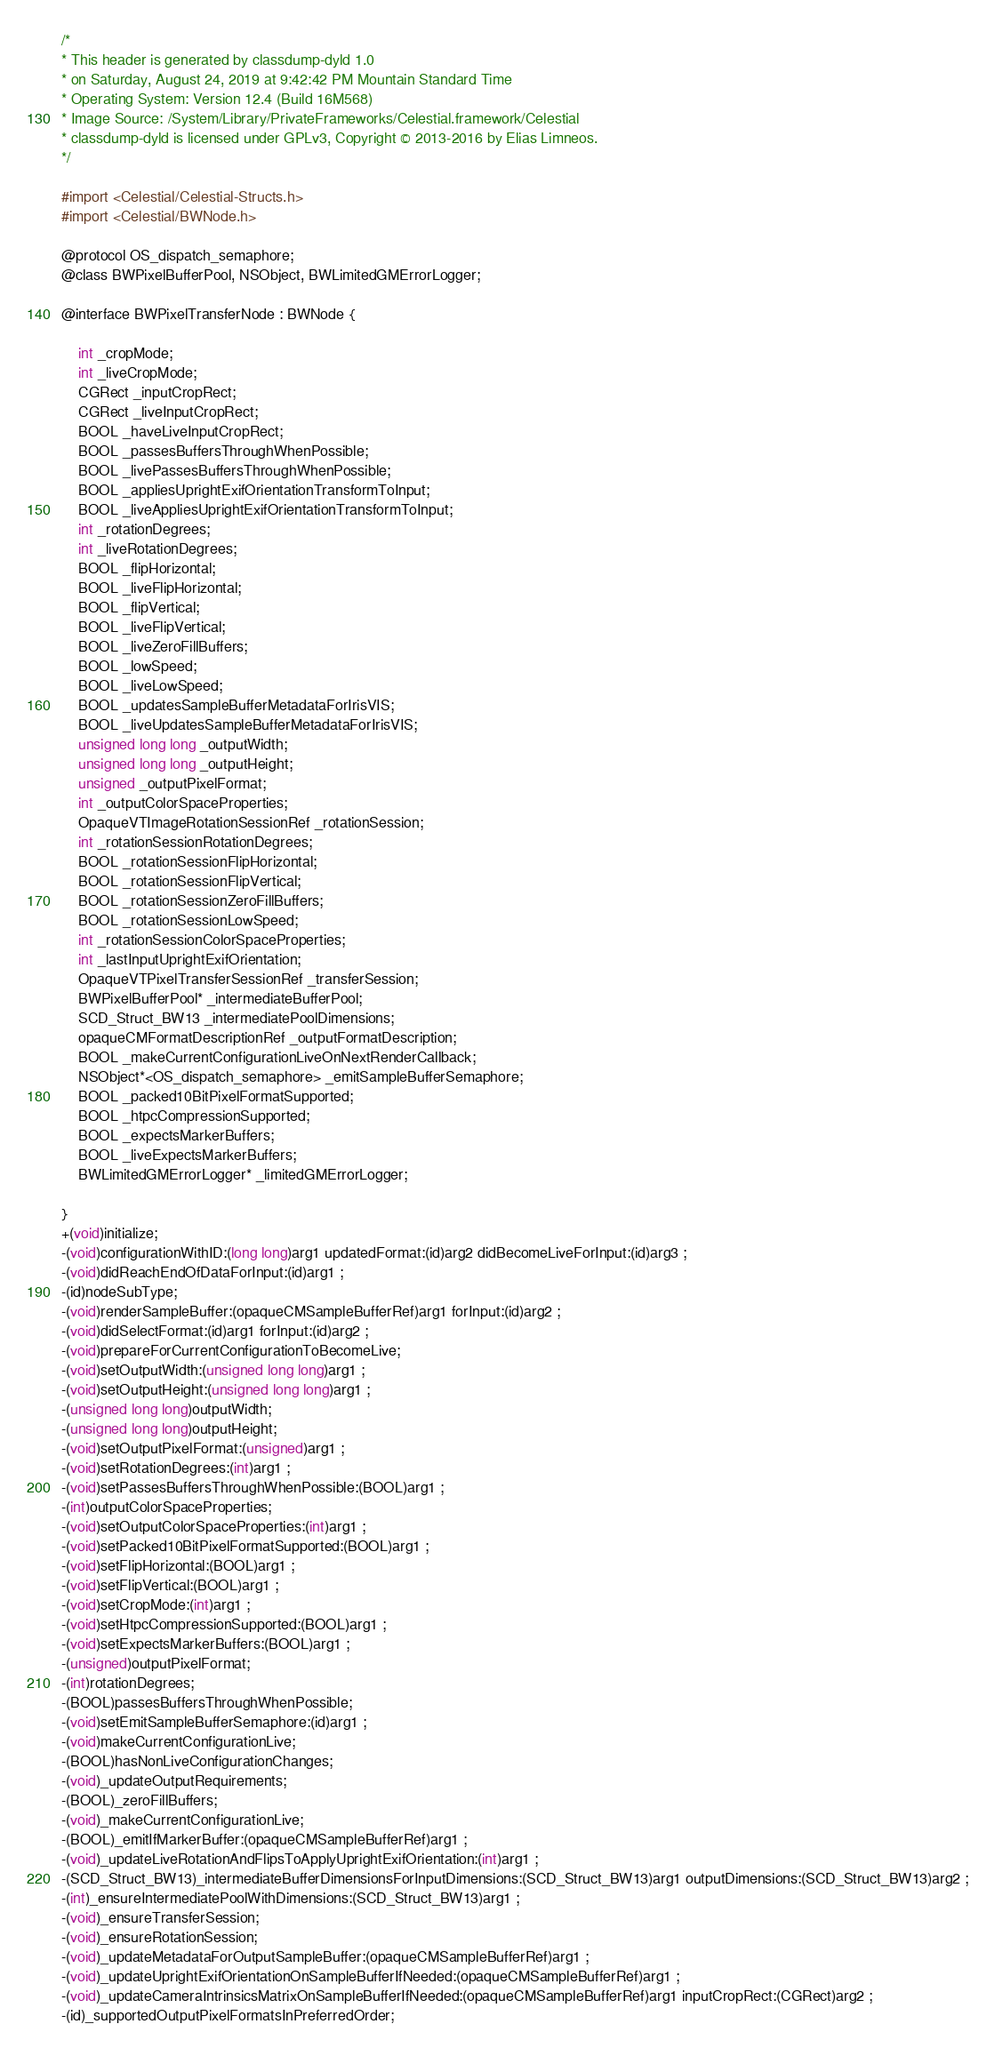<code> <loc_0><loc_0><loc_500><loc_500><_C_>/*
* This header is generated by classdump-dyld 1.0
* on Saturday, August 24, 2019 at 9:42:42 PM Mountain Standard Time
* Operating System: Version 12.4 (Build 16M568)
* Image Source: /System/Library/PrivateFrameworks/Celestial.framework/Celestial
* classdump-dyld is licensed under GPLv3, Copyright © 2013-2016 by Elias Limneos.
*/

#import <Celestial/Celestial-Structs.h>
#import <Celestial/BWNode.h>

@protocol OS_dispatch_semaphore;
@class BWPixelBufferPool, NSObject, BWLimitedGMErrorLogger;

@interface BWPixelTransferNode : BWNode {

	int _cropMode;
	int _liveCropMode;
	CGRect _inputCropRect;
	CGRect _liveInputCropRect;
	BOOL _haveLiveInputCropRect;
	BOOL _passesBuffersThroughWhenPossible;
	BOOL _livePassesBuffersThroughWhenPossible;
	BOOL _appliesUprightExifOrientationTransformToInput;
	BOOL _liveAppliesUprightExifOrientationTransformToInput;
	int _rotationDegrees;
	int _liveRotationDegrees;
	BOOL _flipHorizontal;
	BOOL _liveFlipHorizontal;
	BOOL _flipVertical;
	BOOL _liveFlipVertical;
	BOOL _liveZeroFillBuffers;
	BOOL _lowSpeed;
	BOOL _liveLowSpeed;
	BOOL _updatesSampleBufferMetadataForIrisVIS;
	BOOL _liveUpdatesSampleBufferMetadataForIrisVIS;
	unsigned long long _outputWidth;
	unsigned long long _outputHeight;
	unsigned _outputPixelFormat;
	int _outputColorSpaceProperties;
	OpaqueVTImageRotationSessionRef _rotationSession;
	int _rotationSessionRotationDegrees;
	BOOL _rotationSessionFlipHorizontal;
	BOOL _rotationSessionFlipVertical;
	BOOL _rotationSessionZeroFillBuffers;
	BOOL _rotationSessionLowSpeed;
	int _rotationSessionColorSpaceProperties;
	int _lastInputUprightExifOrientation;
	OpaqueVTPixelTransferSessionRef _transferSession;
	BWPixelBufferPool* _intermediateBufferPool;
	SCD_Struct_BW13 _intermediatePoolDimensions;
	opaqueCMFormatDescriptionRef _outputFormatDescription;
	BOOL _makeCurrentConfigurationLiveOnNextRenderCallback;
	NSObject*<OS_dispatch_semaphore> _emitSampleBufferSemaphore;
	BOOL _packed10BitPixelFormatSupported;
	BOOL _htpcCompressionSupported;
	BOOL _expectsMarkerBuffers;
	BOOL _liveExpectsMarkerBuffers;
	BWLimitedGMErrorLogger* _limitedGMErrorLogger;

}
+(void)initialize;
-(void)configurationWithID:(long long)arg1 updatedFormat:(id)arg2 didBecomeLiveForInput:(id)arg3 ;
-(void)didReachEndOfDataForInput:(id)arg1 ;
-(id)nodeSubType;
-(void)renderSampleBuffer:(opaqueCMSampleBufferRef)arg1 forInput:(id)arg2 ;
-(void)didSelectFormat:(id)arg1 forInput:(id)arg2 ;
-(void)prepareForCurrentConfigurationToBecomeLive;
-(void)setOutputWidth:(unsigned long long)arg1 ;
-(void)setOutputHeight:(unsigned long long)arg1 ;
-(unsigned long long)outputWidth;
-(unsigned long long)outputHeight;
-(void)setOutputPixelFormat:(unsigned)arg1 ;
-(void)setRotationDegrees:(int)arg1 ;
-(void)setPassesBuffersThroughWhenPossible:(BOOL)arg1 ;
-(int)outputColorSpaceProperties;
-(void)setOutputColorSpaceProperties:(int)arg1 ;
-(void)setPacked10BitPixelFormatSupported:(BOOL)arg1 ;
-(void)setFlipHorizontal:(BOOL)arg1 ;
-(void)setFlipVertical:(BOOL)arg1 ;
-(void)setCropMode:(int)arg1 ;
-(void)setHtpcCompressionSupported:(BOOL)arg1 ;
-(void)setExpectsMarkerBuffers:(BOOL)arg1 ;
-(unsigned)outputPixelFormat;
-(int)rotationDegrees;
-(BOOL)passesBuffersThroughWhenPossible;
-(void)setEmitSampleBufferSemaphore:(id)arg1 ;
-(void)makeCurrentConfigurationLive;
-(BOOL)hasNonLiveConfigurationChanges;
-(void)_updateOutputRequirements;
-(BOOL)_zeroFillBuffers;
-(void)_makeCurrentConfigurationLive;
-(BOOL)_emitIfMarkerBuffer:(opaqueCMSampleBufferRef)arg1 ;
-(void)_updateLiveRotationAndFlipsToApplyUprightExifOrientation:(int)arg1 ;
-(SCD_Struct_BW13)_intermediateBufferDimensionsForInputDimensions:(SCD_Struct_BW13)arg1 outputDimensions:(SCD_Struct_BW13)arg2 ;
-(int)_ensureIntermediatePoolWithDimensions:(SCD_Struct_BW13)arg1 ;
-(void)_ensureTransferSession;
-(void)_ensureRotationSession;
-(void)_updateMetadataForOutputSampleBuffer:(opaqueCMSampleBufferRef)arg1 ;
-(void)_updateUprightExifOrientationOnSampleBufferIfNeeded:(opaqueCMSampleBufferRef)arg1 ;
-(void)_updateCameraIntrinsicsMatrixOnSampleBufferIfNeeded:(opaqueCMSampleBufferRef)arg1 inputCropRect:(CGRect)arg2 ;
-(id)_supportedOutputPixelFormatsInPreferredOrder;</code> 